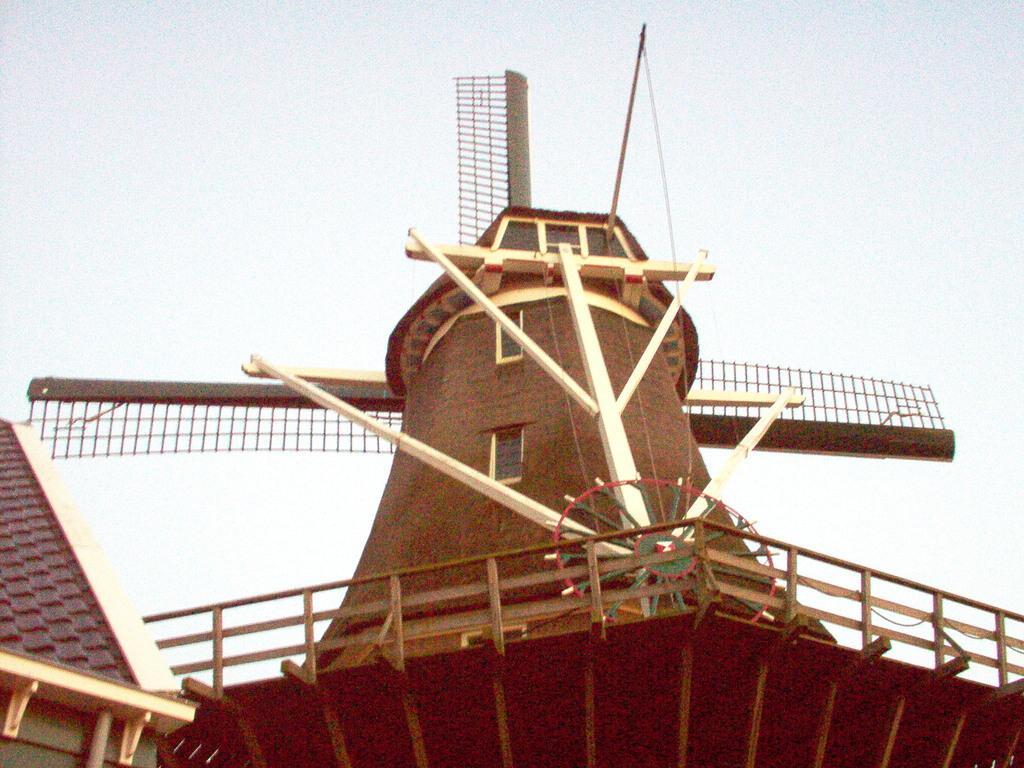In one or two sentences, can you explain what this image depicts? In this picture we can see few houses. 